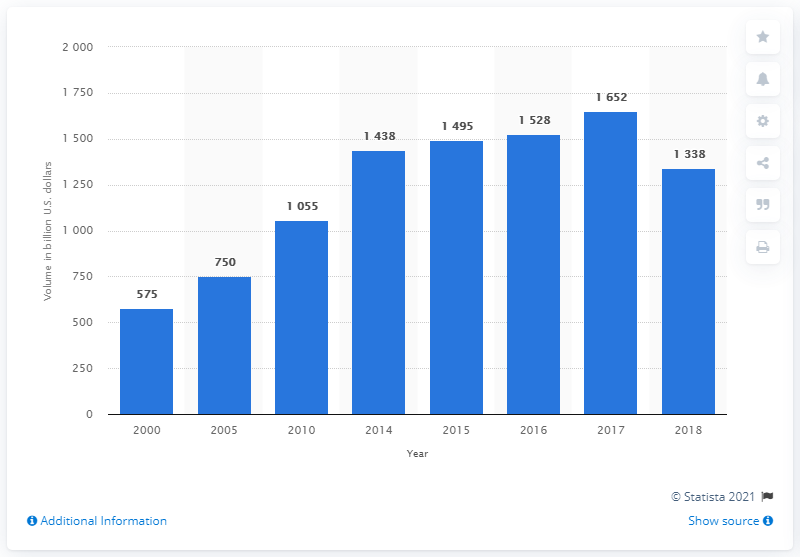List a handful of essential elements in this visual. In 2018, the volume of new issuance in the corporate debt market of the United States was 1,338. 